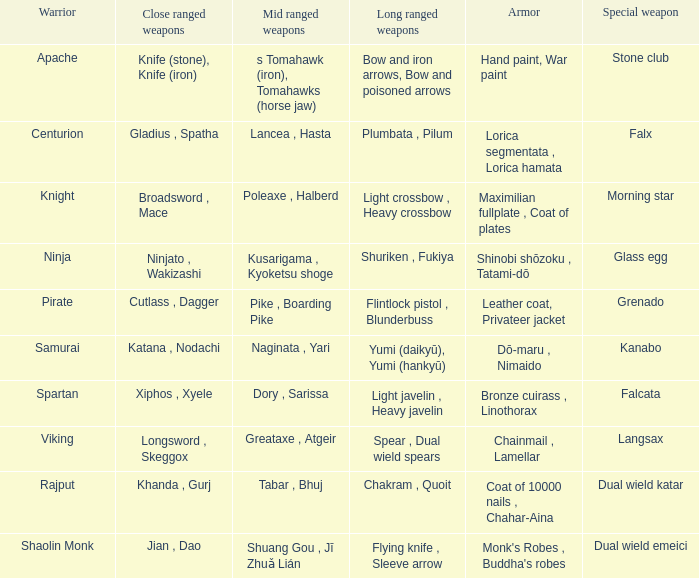If the near-range weapons are the knife (stone) and knife (iron), what are the far-range weapons? Bow and iron arrows, Bow and poisoned arrows. 